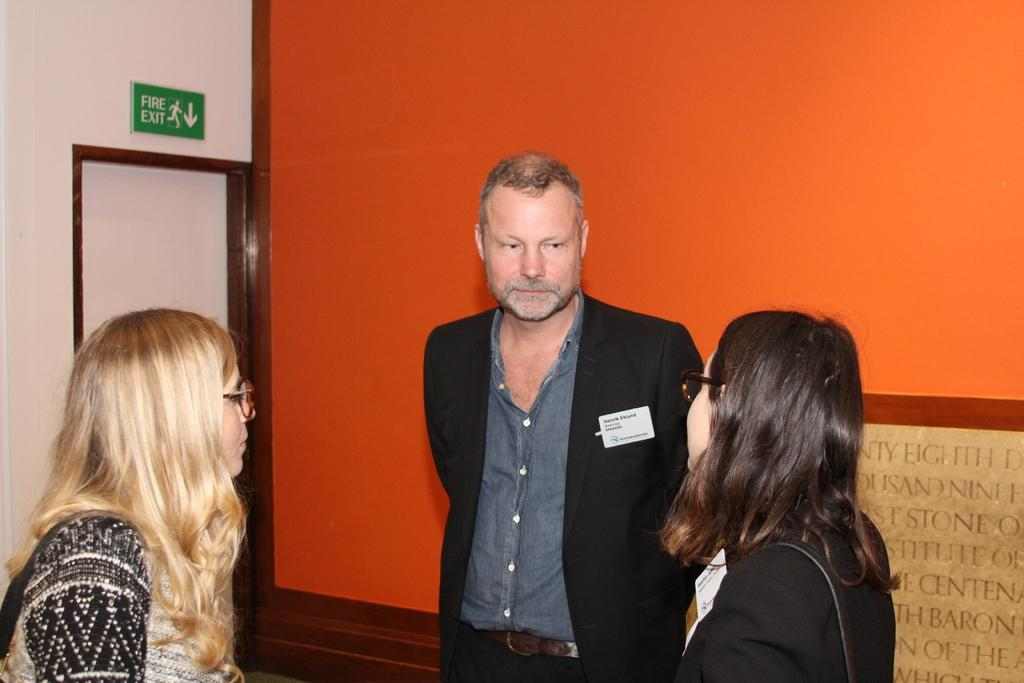How many people are in the foreground of the image? There are three people in the foreground of the image. What can be seen in the background of the image? There is a wall in the background of the image. Where is the fire exit board located in the image? The fire exit board is on the left side of the image. What is below the fire exit board? There is a door below the fire exit board. What type of corn is being sung about in the image? There is no corn or singing present in the image. What material is the wool made of in the image? There is no wool present in the image. 